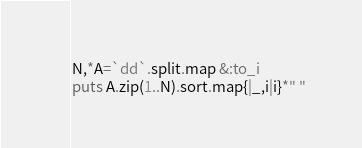Convert code to text. <code><loc_0><loc_0><loc_500><loc_500><_Ruby_>N,*A=`dd`.split.map &:to_i
puts A.zip(1..N).sort.map{|_,i|i}*" "</code> 